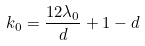<formula> <loc_0><loc_0><loc_500><loc_500>k _ { 0 } = \frac { 1 2 \lambda _ { 0 } } { d } + 1 - d</formula> 